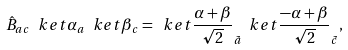Convert formula to latex. <formula><loc_0><loc_0><loc_500><loc_500>\hat { B } _ { a c } \ k e t { \alpha } _ { a } \ k e t { \beta } _ { c } = \ k e t { \frac { \alpha + \beta } { \sqrt { 2 } } } _ { \tilde { a } } \ k e t { \frac { - \alpha + \beta } { \sqrt { 2 } } } _ { \tilde { c } } ,</formula> 